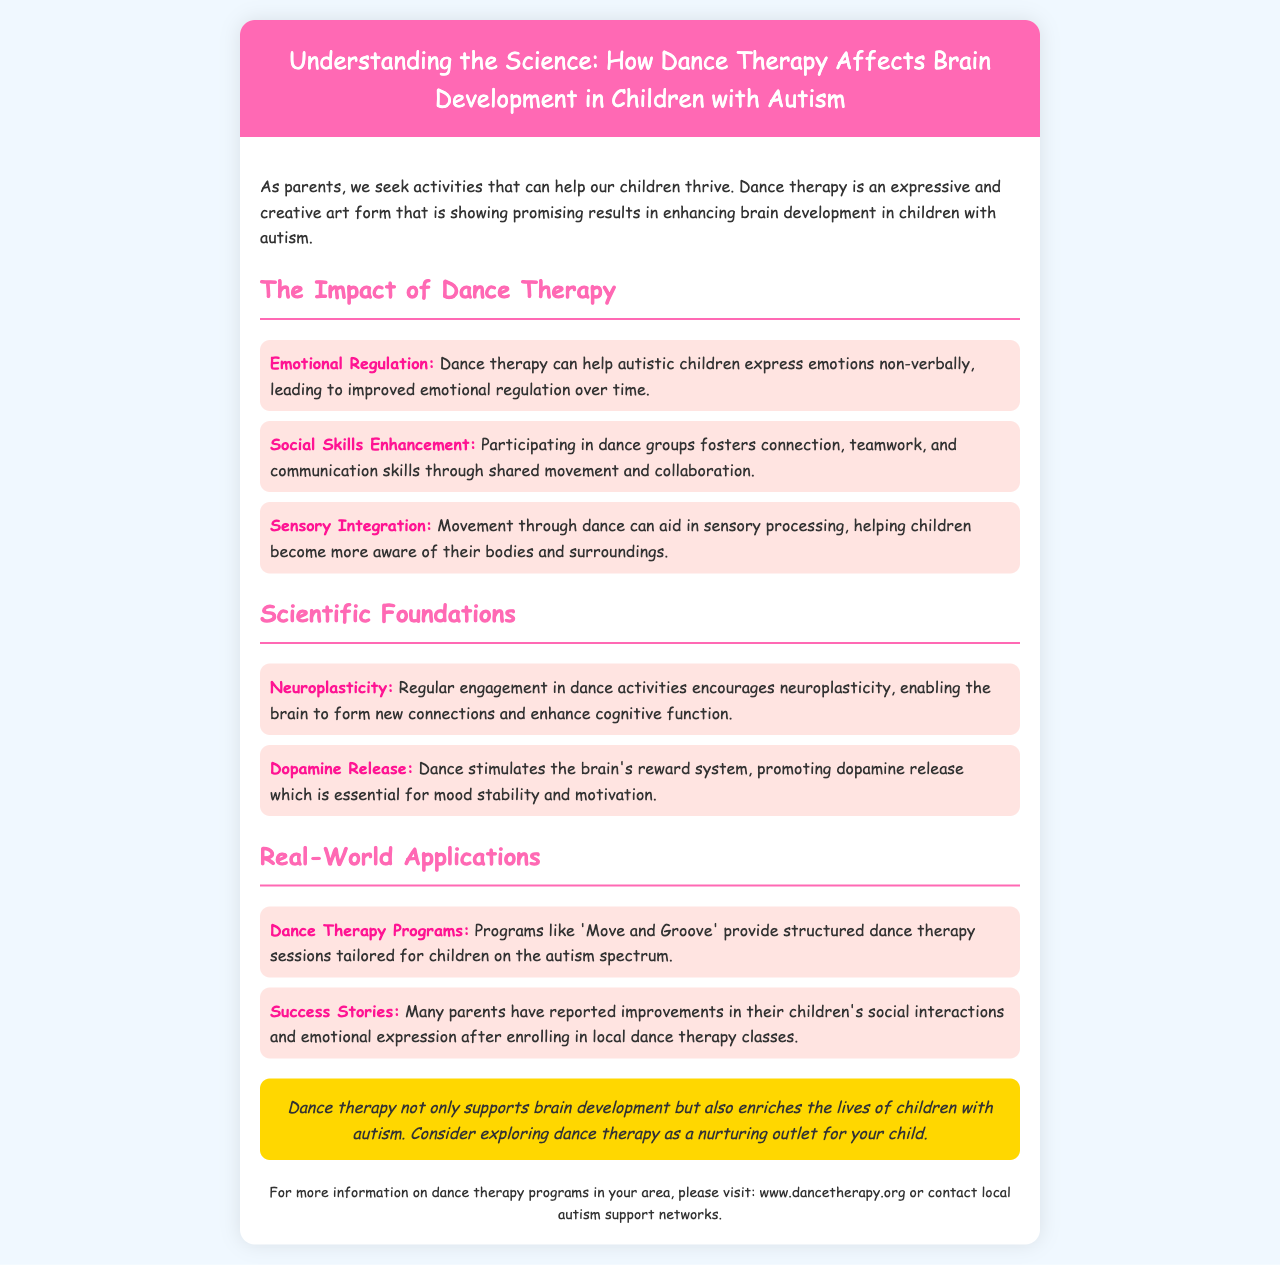What is the title of the brochure? The title of the brochure is prominently displayed at the top and provides the main topic of discussion.
Answer: Understanding the Science: How Dance Therapy Affects Brain Development in Children with Autism What is one benefit of dance therapy mentioned in the brochure? The brochure outlines specific benefits related to dance therapy, including emotional regulation.
Answer: Emotional Regulation What does dance therapy help enhance according to the document? The document lists several areas that dance therapy enhances, one of which is social skills.
Answer: Social Skills Enhancement Which neurotransmitter is promoted by dance according to the scientific foundations? The document specifically mentions a neurotransmitter that is released due to dance activity, impacting mood and motivation.
Answer: Dopamine What type of programs does the brochure highlight for children with autism? The brochure describes specific programs designed to utilize dance therapy for autistic children.
Answer: Dance Therapy Programs How does dance therapy support brain development? The document explains that regular engagement in dance activities encourages a specific brain function related to forming connections.
Answer: Neuroplasticity What is the background color of the brochure? The color scheme of the brochure is aesthetically designed, particularly the background.
Answer: #f0f8ff What is the contact information for more details on dance therapy programs? The document provides a resource for parents looking for more information.
Answer: www.dancetherapy.org 